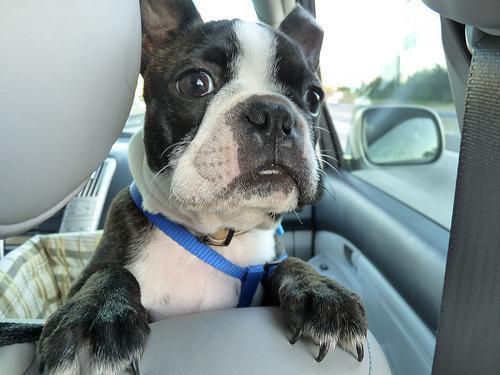How many side mirrors can be seen in the photo?
Give a very brief answer. 1. 